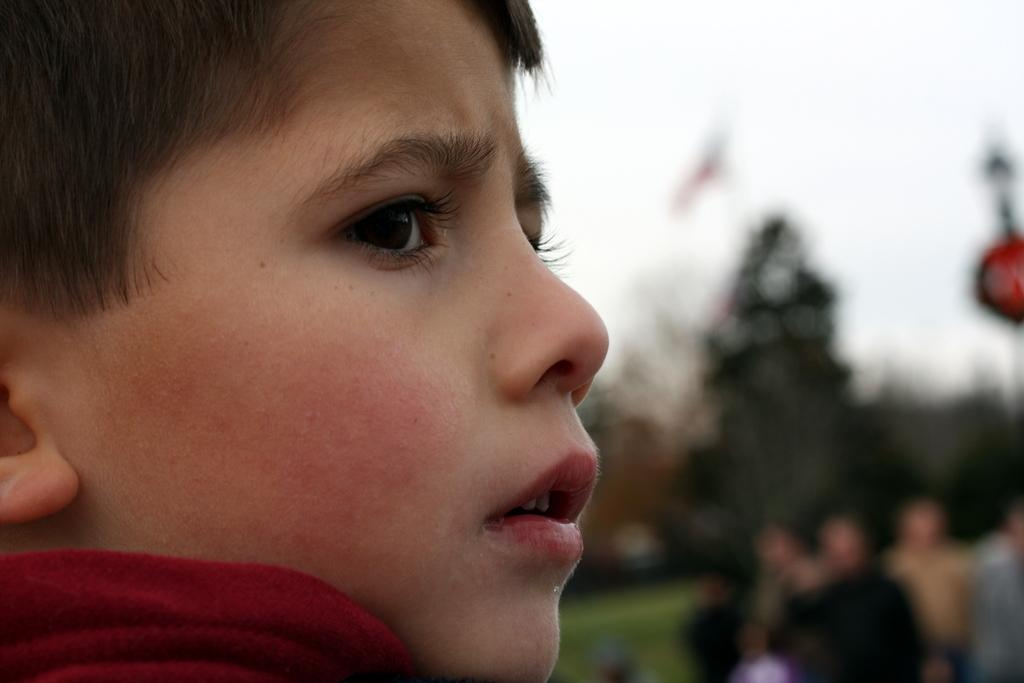Who is the main subject in the image? There is a boy in the image. What can be seen in the background of the image? There are people, trees, and the sky visible in the background of the image. How would you describe the quality of the image? The image is blurry. Where is the kitty sitting in the image? There is no kitty present in the image. What type of sweater is the boy wearing in the image? The provided facts do not mention the boy's clothing, so we cannot determine if he is wearing a sweater or its type. 